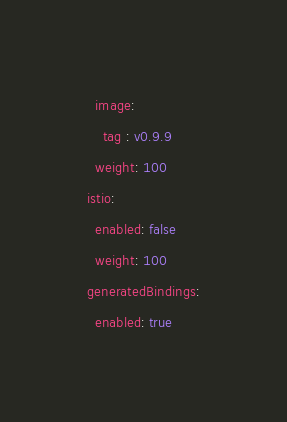Convert code to text. <code><loc_0><loc_0><loc_500><loc_500><_YAML_>  image:
    tag : v0.9.9
  weight: 100
istio:
  enabled: false
  weight: 100
generatedBindings:
  enabled: true
</code> 